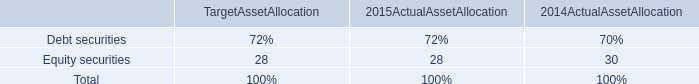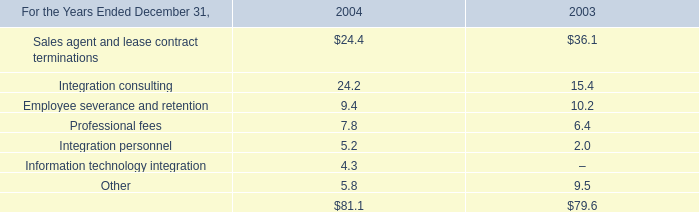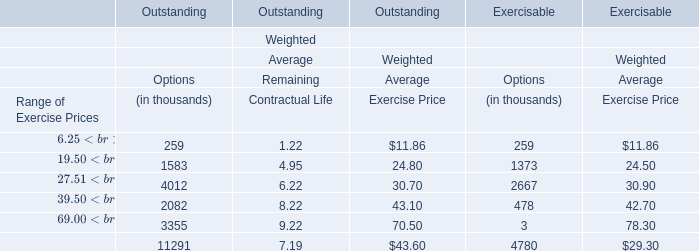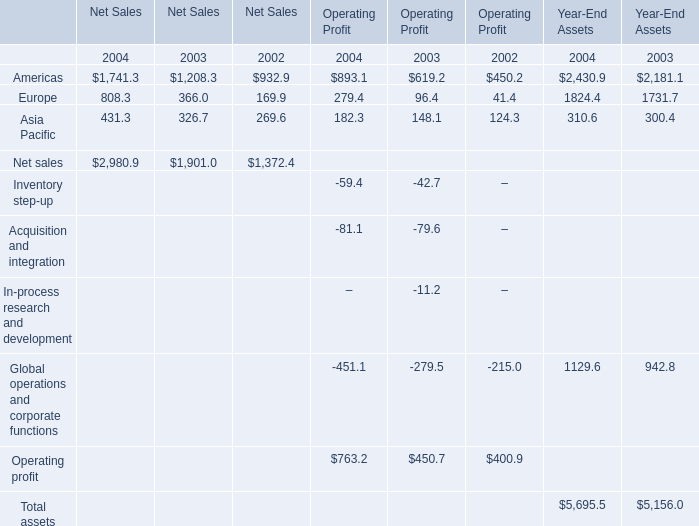Which year is Europe of operating profit the most? 
Answer: 2004. 